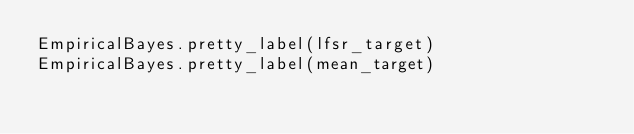Convert code to text. <code><loc_0><loc_0><loc_500><loc_500><_Julia_>EmpiricalBayes.pretty_label(lfsr_target)
EmpiricalBayes.pretty_label(mean_target)
</code> 